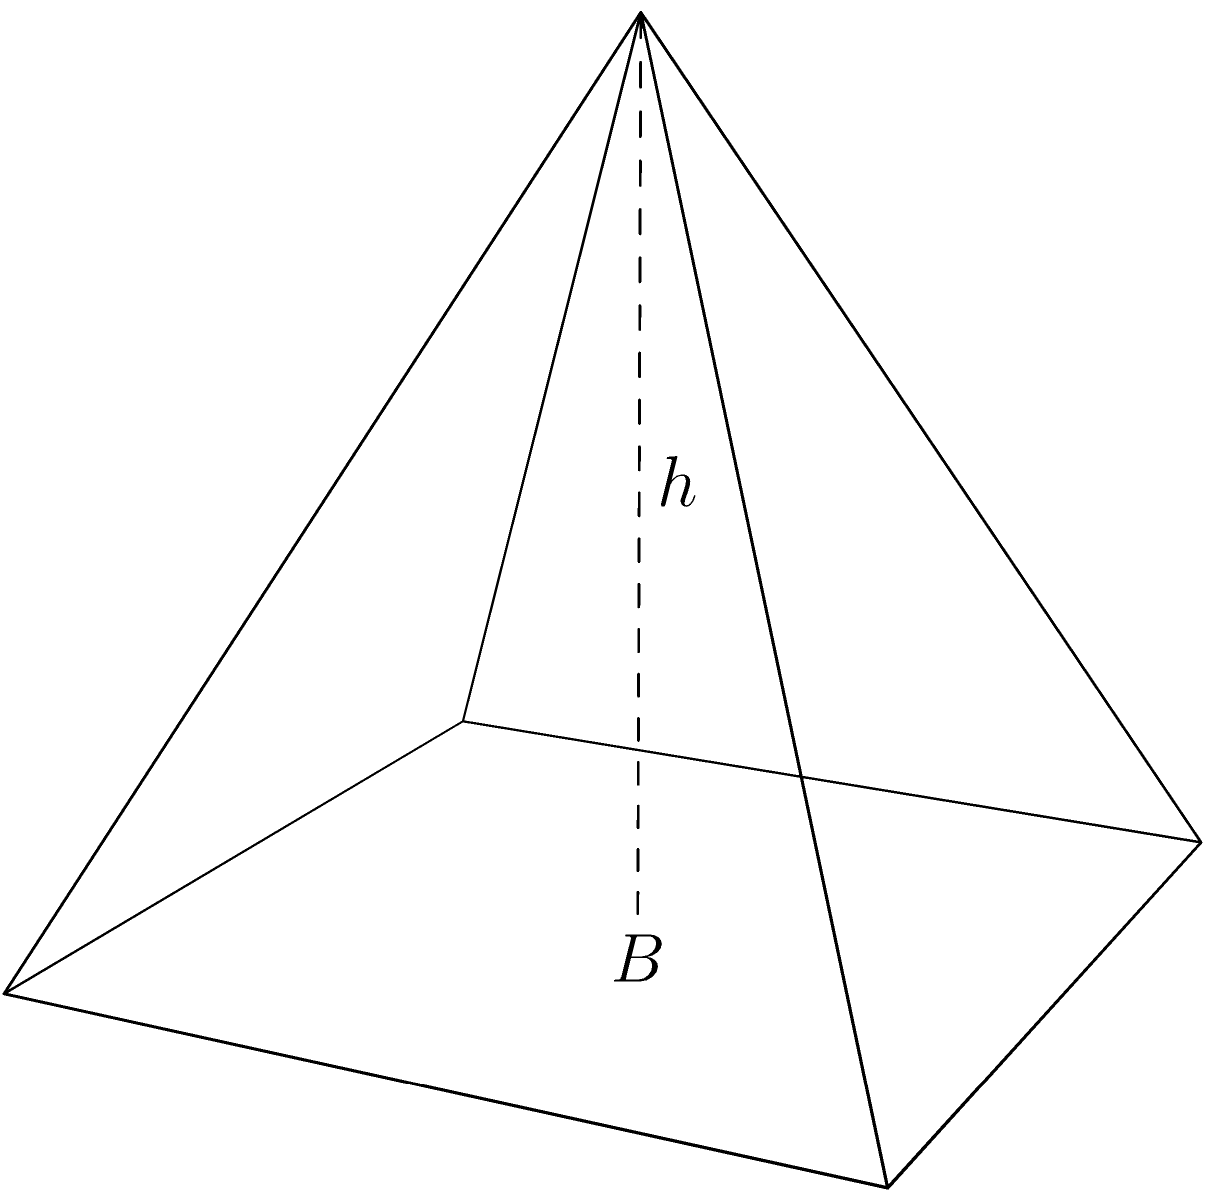During a quiet afternoon at the library, you come across a geometry book with an intriguing problem. It shows a pyramid with a square base of area 64 square meters and a height of 12 meters. What is the volume of this pyramid? Let's approach this step-by-step:

1) The formula for the volume of a pyramid is:

   $$V = \frac{1}{3} \times B \times h$$

   where $V$ is the volume, $B$ is the area of the base, and $h$ is the height.

2) We are given:
   - Base area, $B = 64$ square meters
   - Height, $h = 12$ meters

3) Let's substitute these values into our formula:

   $$V = \frac{1}{3} \times 64 \times 12$$

4) Now, let's calculate:
   
   $$V = \frac{1}{3} \times 768 = 256$$

5) Therefore, the volume of the pyramid is 256 cubic meters.

This problem reminds us that even in complex shapes, simple formulas can lead us to elegant solutions, much like how books can offer clarity in confusing times.
Answer: 256 cubic meters 